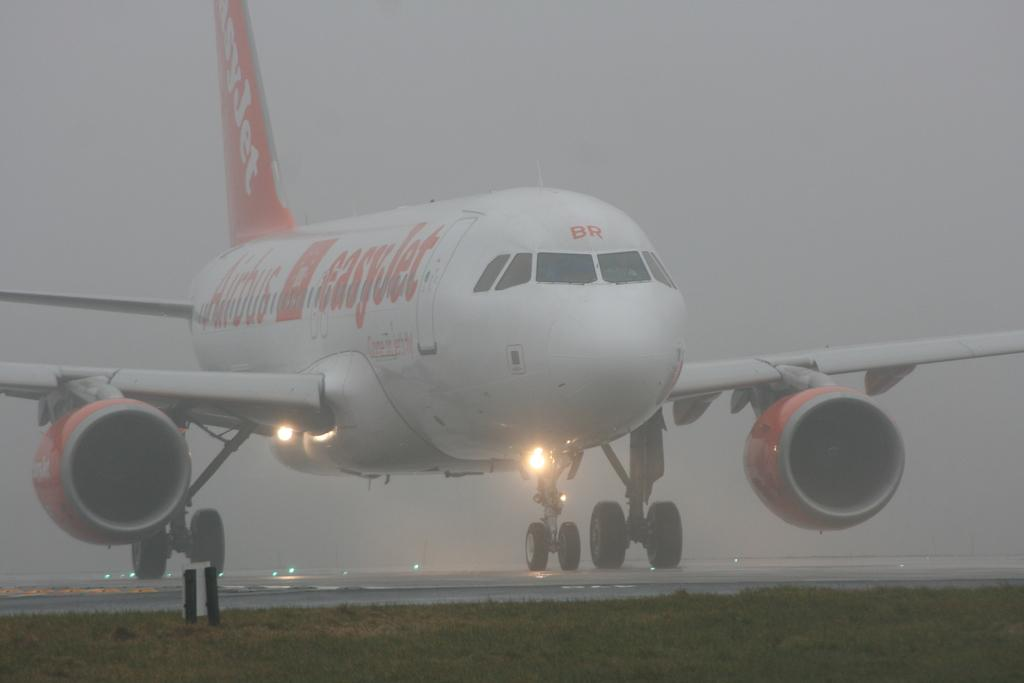What is the main subject of the image? The main subject of the image is an airplane. Where is the airplane located in the image? The airplane is on a runway. What can be seen near the airplane? There are lights near the airplane. What feature of the airplane is visible in the image? The airplane has wheels. What is visible in the background of the image? There is fog visible in the background of the image. Can you tell me how many tickets are needed to enter the zoo in the image? There is no zoo present in the image, so it is not possible to determine the number of tickets needed to enter. 